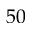<formula> <loc_0><loc_0><loc_500><loc_500>5 0</formula> 